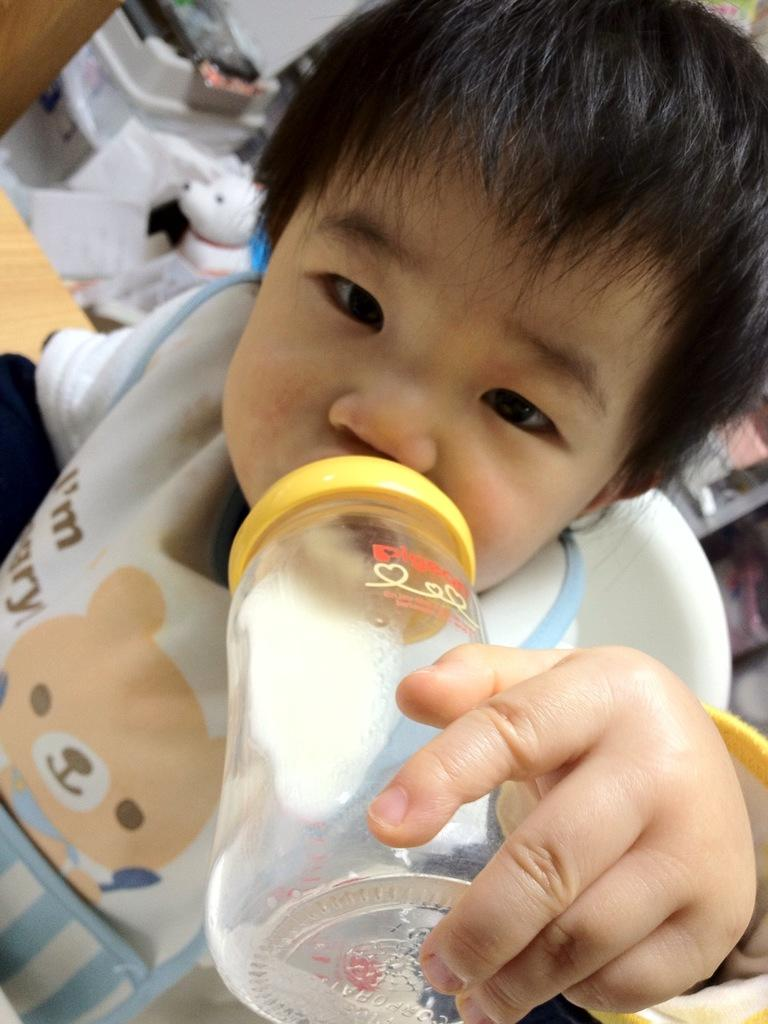What is the main subject of the image? There is a child in the image. What is the child doing in the image? The child is sitting on a chair. What object can be seen in the image besides the child? There is a bottle in the image. What type of sign can be seen hanging from the child's neck in the image? There is no sign present in the image; the child is simply sitting on a chair with a bottle nearby. 